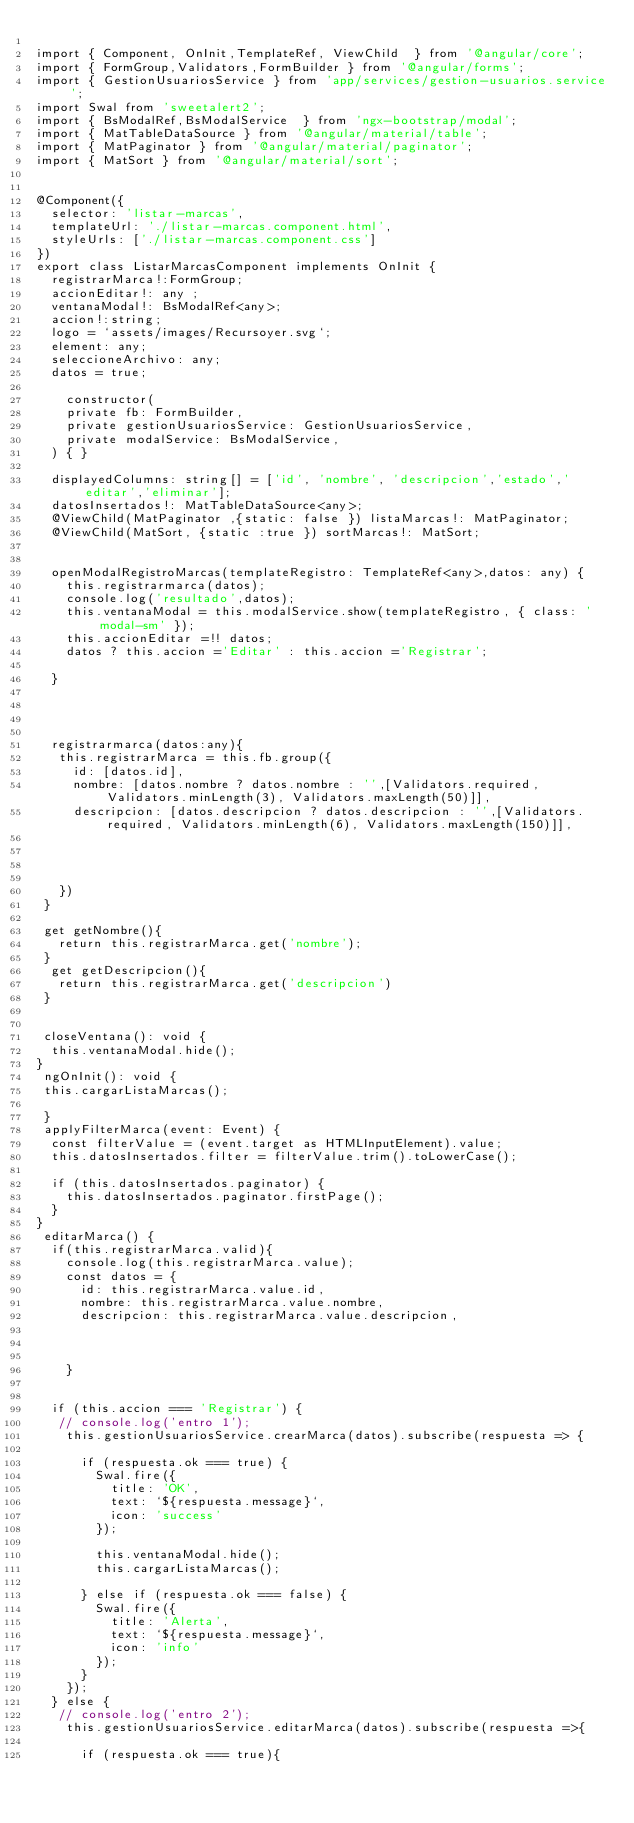Convert code to text. <code><loc_0><loc_0><loc_500><loc_500><_TypeScript_>
import { Component, OnInit,TemplateRef, ViewChild  } from '@angular/core';
import { FormGroup,Validators,FormBuilder } from '@angular/forms';
import { GestionUsuariosService } from 'app/services/gestion-usuarios.service';
import Swal from 'sweetalert2';
import { BsModalRef,BsModalService  } from 'ngx-bootstrap/modal';
import { MatTableDataSource } from '@angular/material/table';
import { MatPaginator } from '@angular/material/paginator';
import { MatSort } from '@angular/material/sort';


@Component({
  selector: 'listar-marcas',
  templateUrl: './listar-marcas.component.html',
  styleUrls: ['./listar-marcas.component.css']
})
export class ListarMarcasComponent implements OnInit {
  registrarMarca!:FormGroup;
  accionEditar!: any ;
  ventanaModal!: BsModalRef<any>;
  accion!:string;
  logo = `assets/images/Recursoyer.svg`;
  element: any;
  seleccioneArchivo: any;
  datos = true;

    constructor(
    private fb: FormBuilder,
    private gestionUsuariosService: GestionUsuariosService,
    private modalService: BsModalService,
  ) { }

  displayedColumns: string[] = ['id', 'nombre', 'descripcion','estado','editar','eliminar'];
  datosInsertados!: MatTableDataSource<any>;
  @ViewChild(MatPaginator ,{static: false }) listaMarcas!: MatPaginator;
  @ViewChild(MatSort, {static :true }) sortMarcas!: MatSort;
 
   
  openModalRegistroMarcas(templateRegistro: TemplateRef<any>,datos: any) {
    this.registrarmarca(datos);
    console.log('resultado',datos);
    this.ventanaModal = this.modalService.show(templateRegistro, { class: 'modal-sm' });
    this.accionEditar =!! datos;
    datos ? this.accion ='Editar' : this.accion ='Registrar';
   
  }




  registrarmarca(datos:any){
   this.registrarMarca = this.fb.group({
     id: [datos.id],
     nombre: [datos.nombre ? datos.nombre : '',[Validators.required, Validators.minLength(3), Validators.maxLength(50)]],
     descripcion: [datos.descripcion ? datos.descripcion : '',[Validators.required, Validators.minLength(6), Validators.maxLength(150)]],

  


   })
 }

 get getNombre(){
   return this.registrarMarca.get('nombre');
 }
  get getDescripcion(){
   return this.registrarMarca.get('descripcion')
 }


 closeVentana(): void {
  this.ventanaModal.hide();
}
 ngOnInit(): void {
 this.cargarListaMarcas();
  
 }
 applyFilterMarca(event: Event) {
  const filterValue = (event.target as HTMLInputElement).value;
  this.datosInsertados.filter = filterValue.trim().toLowerCase();

  if (this.datosInsertados.paginator) {
    this.datosInsertados.paginator.firstPage();
  }
}
 editarMarca() {
  if(this.registrarMarca.valid){
    console.log(this.registrarMarca.value);
    const datos = {
      id: this.registrarMarca.value.id,
      nombre: this.registrarMarca.value.nombre,
      descripcion: this.registrarMarca.value.descripcion,
   
     
 
    }


  if (this.accion === 'Registrar') {
   // console.log('entro 1');
    this.gestionUsuariosService.crearMarca(datos).subscribe(respuesta => {

      if (respuesta.ok === true) {
        Swal.fire({
          title: 'OK',
          text: `${respuesta.message}`,
          icon: 'success'
        });
        
        this.ventanaModal.hide();
        this.cargarListaMarcas();
      
      } else if (respuesta.ok === false) {
        Swal.fire({
          title: 'Alerta',
          text: `${respuesta.message}`,
          icon: 'info'
        });
      }
    });
  } else {
   // console.log('entro 2');
    this.gestionUsuariosService.editarMarca(datos).subscribe(respuesta =>{
  
      if (respuesta.ok === true){</code> 